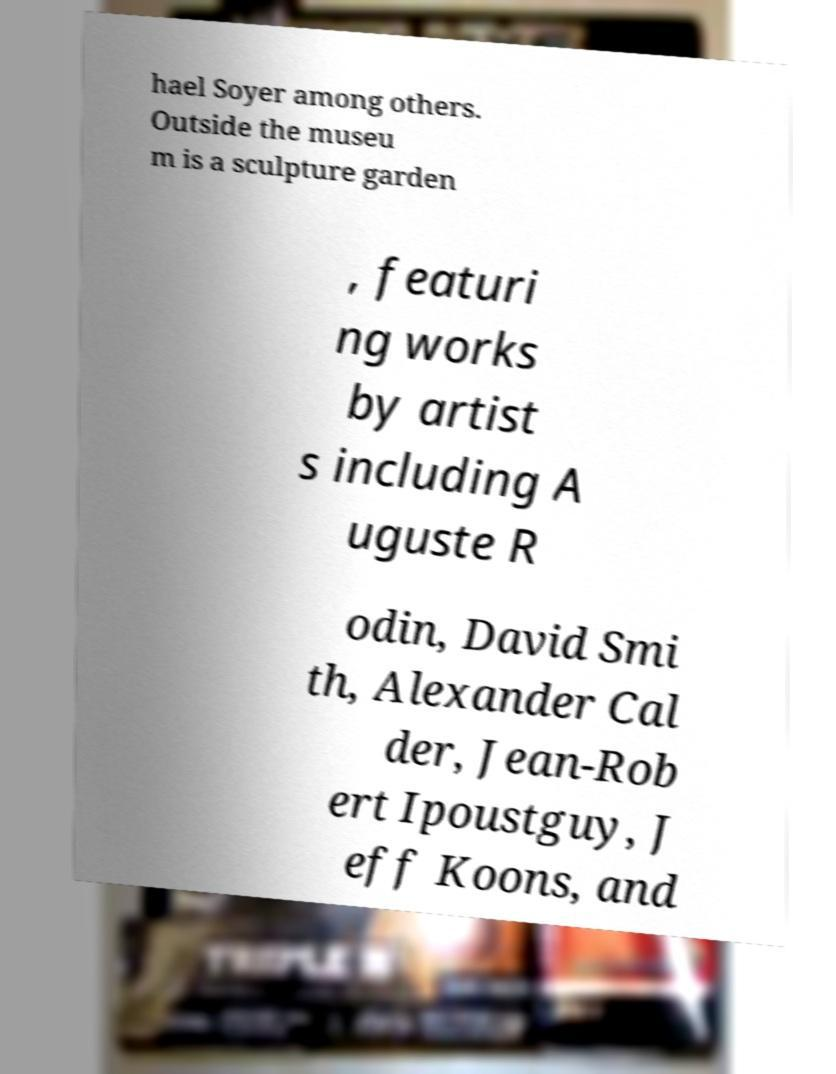Could you extract and type out the text from this image? hael Soyer among others. Outside the museu m is a sculpture garden , featuri ng works by artist s including A uguste R odin, David Smi th, Alexander Cal der, Jean-Rob ert Ipoustguy, J eff Koons, and 